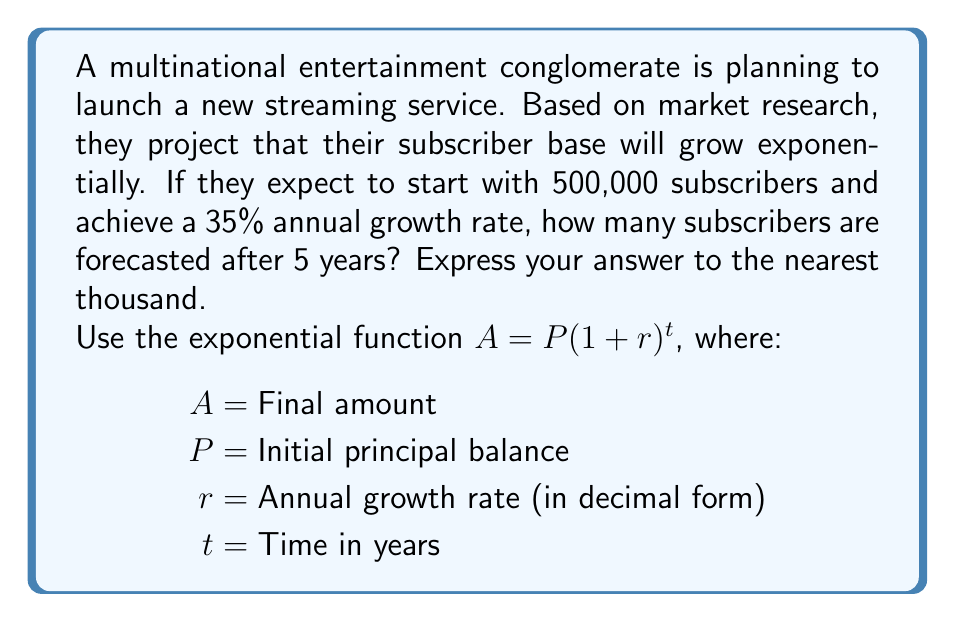Can you answer this question? To solve this problem, we'll use the exponential growth function:

$A = P(1 + r)^t$

Where:
$P = 500,000$ (initial number of subscribers)
$r = 0.35$ (35% annual growth rate expressed as a decimal)
$t = 5$ years

Let's substitute these values into the equation:

$A = 500,000(1 + 0.35)^5$

Now, let's solve step-by-step:

1) First, calculate $(1 + 0.35)$:
   $1 + 0.35 = 1.35$

2) Now, we have:
   $A = 500,000(1.35)^5$

3) Calculate $1.35^5$:
   $1.35^5 \approx 4.4815$

4) Multiply by 500,000:
   $500,000 \times 4.4815 = 2,240,750$

5) Rounding to the nearest thousand:
   $2,240,750 \approx 2,241,000$

Therefore, after 5 years, the streaming service is forecasted to have approximately 2,241,000 subscribers.
Answer: 2,241,000 subscribers 